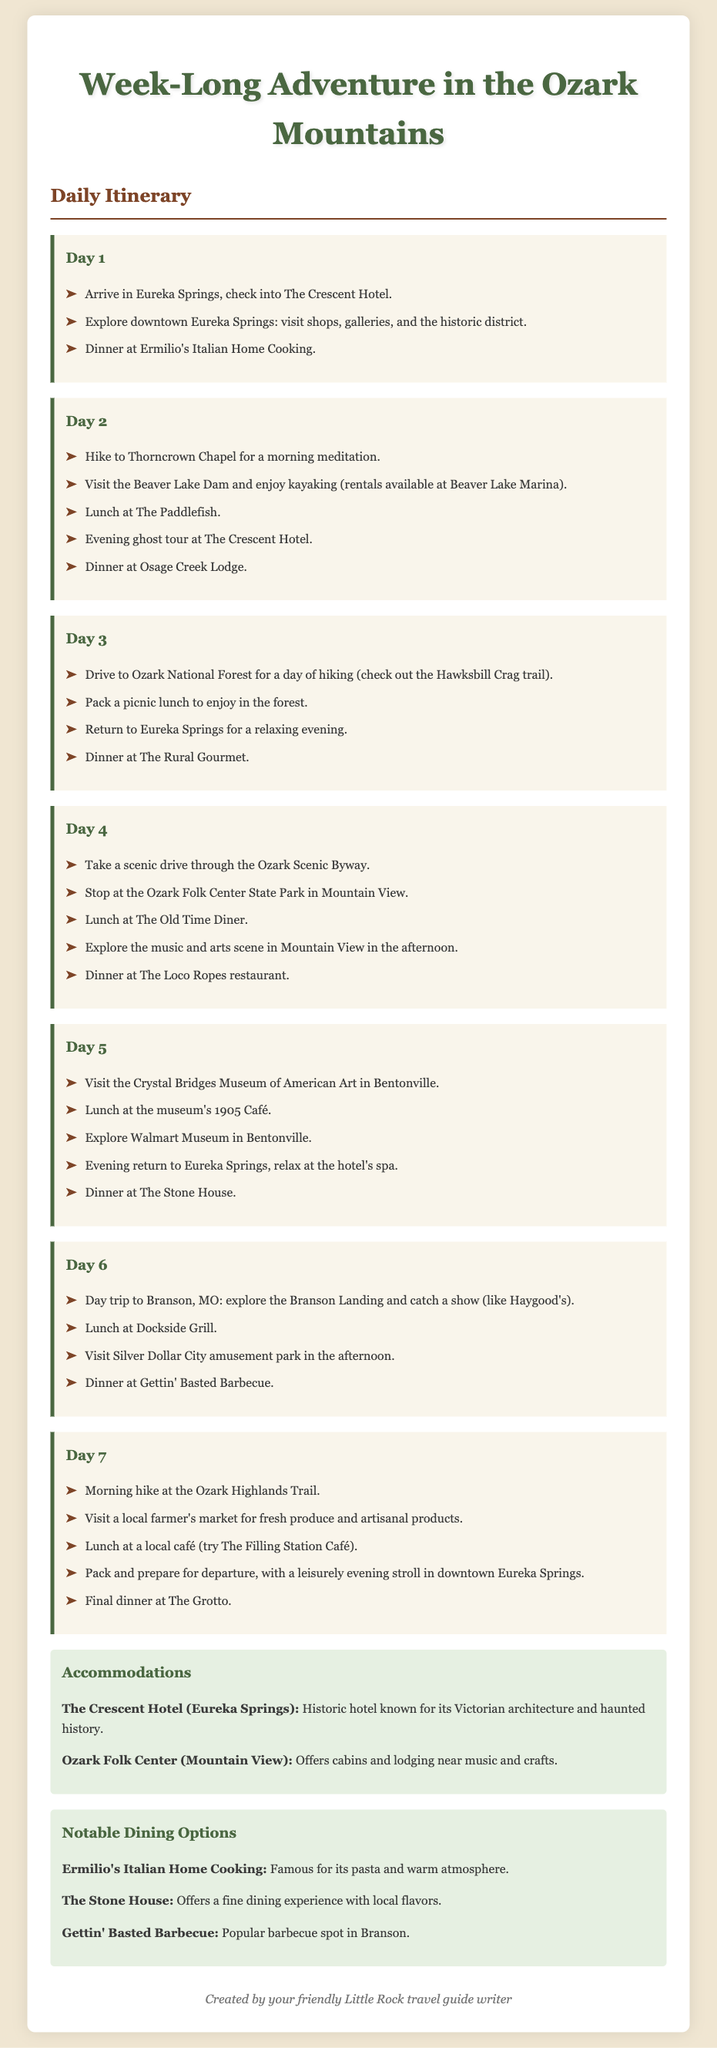What is the first accommodation listed? The first accommodation mentioned in the document is The Crescent Hotel, which is located in Eureka Springs.
Answer: The Crescent Hotel How many days are planned in the itinerary? The document outlines a detailed itinerary for a week-long trip, indicating a total of seven days of activities.
Answer: Seven days What is one activity for Day 4? On Day 4, one activity is to stop at the Ozark Folk Center State Park in Mountain View as part of a scenic drive through the Ozark Scenic Byway.
Answer: Stop at the Ozark Folk Center State Park What is the last dining option mentioned? The last dining option listed in the document is The Grotto, which is chosen for the final dinner.
Answer: The Grotto Which day includes a visit to Crystal Bridges Museum? Day 5 includes a visit to the Crystal Bridges Museum of American Art in Bentonville.
Answer: Day 5 What type of tour is scheduled for the evening of Day 2? The evening of Day 2 includes a ghost tour at The Crescent Hotel.
Answer: Ghost tour Where is lunch on Day 6? On Day 6, lunch is at Dockside Grill during the day trip to Branson.
Answer: Dockside Grill Which restaurant is known for barbecue in Branson? Gettin' Basted Barbecue is mentioned as a popular restaurant for barbecue in Branson.
Answer: Gettin' Basted Barbecue 